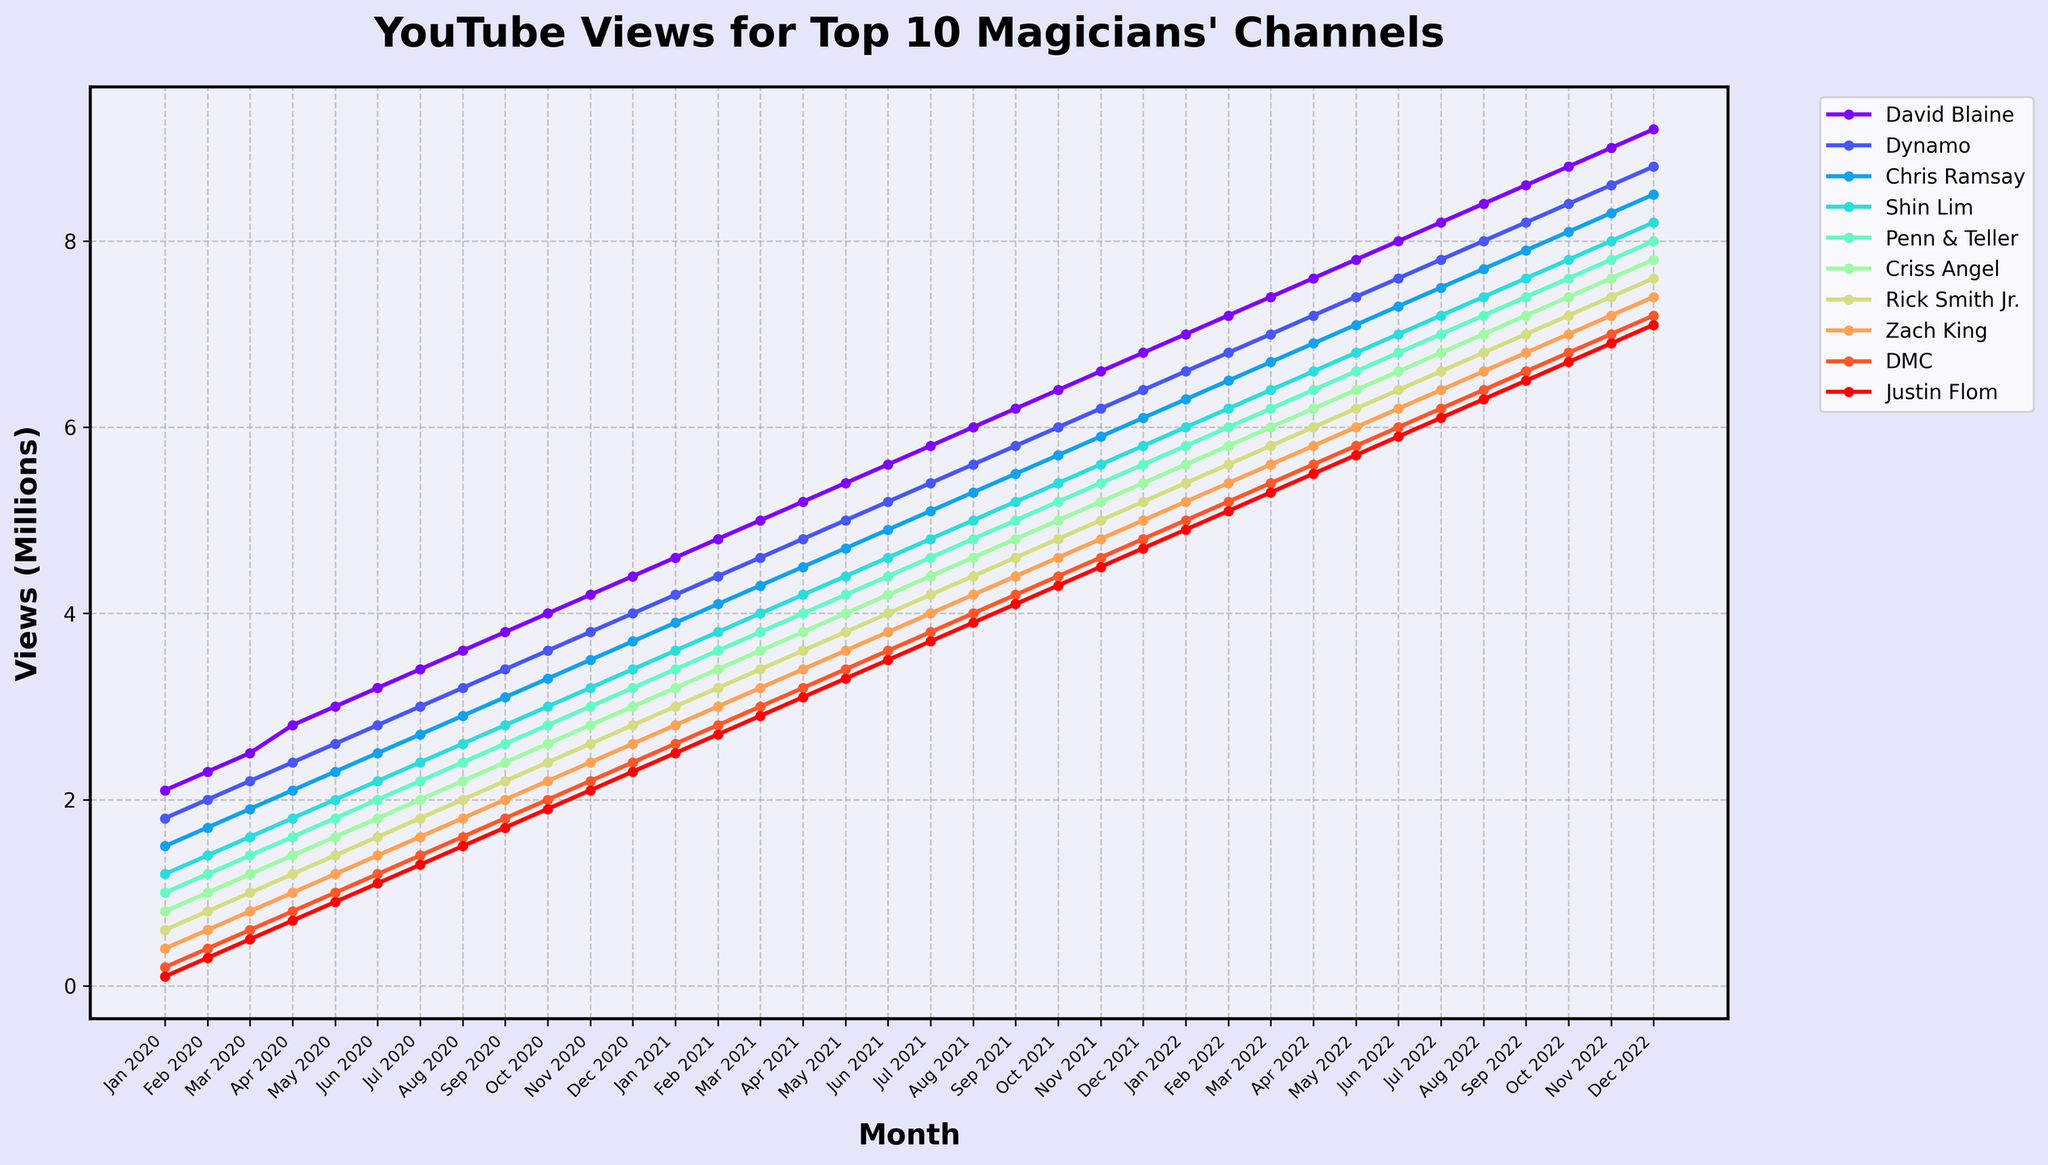What's the trend for David Blaine's YouTube views over the 3-year period? David Blaine's YouTube views show a consistent and steady increase from January 2020 to December 2022. The line representing his data points rises gradually each month, indicating a continuous rise in views.
Answer: Consistent increase Which magician had the least number of views in January 2020? By observing the starting points of each line in January 2020, Justin Flom’s data line is the lowest, starting at 0.1 million views, which is lower than the starting points of all other magicians.
Answer: Justin Flom Who had more views at the end of 2021: Criss Angel or Rick Smith Jr.? By comparing the end points of Criss Angel and Rick Smith Jr.'s lines in December 2021, Criss Angel's line is slightly higher at 5.8 million views compared to Rick Smith Jr.’s 5.4 million views.
Answer: Criss Angel What is the overall increase in views for Dynamo from January 2020 to December 2022? Dynamo's views started at 1.8 million in January 2020 and increased to 8.8 million by December 2022. The overall increase can be calculated as 8.8 - 1.8 = 7 million views.
Answer: 7 million Compare the slopes of the lines representing Zach King and DMC. Which magician's YouTube views grew faster? By analyzing the angles of the lines, Zach King's line is steeper than DMC’s. This indicates that Zach King's views increased at a faster rate compared to DMC’s.
Answer: Zach King Which magician's views did not show any decline or leveling off across the 3 years? All magicians’ lines show a consistent upward trend without any declines or flat periods, but David Blaine’s line, in particular, is smooth and consistently rising without fluctuations.
Answer: David Blaine Identify the month where all magicians' views collectively first surpassed 5 million views. Observing the lines, in December 2020, Shin Lim’s views reached 3.4 million, which is the last month when not all magicians surpassed 5 million views. From January 2021 onward, all magicians had more than 5 million views.
Answer: January 2021 Which magician had the steepest increase in views between June 2021 and September 2021? Comparing the lines, they all increase, but Criss Angel's line has the steepest slope during this period, showing the greatest increase between the two months.
Answer: Criss Angel Among Penn & Teller and Chris Ramsay, who had a higher number of views throughout the 3 years? By tracing the lines of both magicians, it is apparent that Chris Ramsay’s line is always consistently higher than Penn & Teller’s line throughout the 3-year period.
Answer: Chris Ramsay 